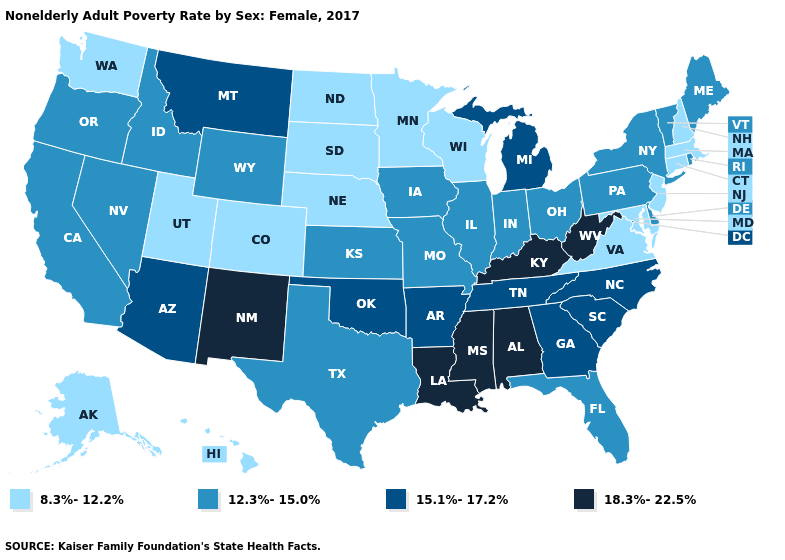What is the value of Tennessee?
Answer briefly. 15.1%-17.2%. Name the states that have a value in the range 12.3%-15.0%?
Keep it brief. California, Delaware, Florida, Idaho, Illinois, Indiana, Iowa, Kansas, Maine, Missouri, Nevada, New York, Ohio, Oregon, Pennsylvania, Rhode Island, Texas, Vermont, Wyoming. What is the highest value in the South ?
Short answer required. 18.3%-22.5%. Name the states that have a value in the range 12.3%-15.0%?
Short answer required. California, Delaware, Florida, Idaho, Illinois, Indiana, Iowa, Kansas, Maine, Missouri, Nevada, New York, Ohio, Oregon, Pennsylvania, Rhode Island, Texas, Vermont, Wyoming. Does Rhode Island have the lowest value in the Northeast?
Keep it brief. No. What is the value of Missouri?
Quick response, please. 12.3%-15.0%. What is the highest value in the USA?
Quick response, please. 18.3%-22.5%. Name the states that have a value in the range 15.1%-17.2%?
Be succinct. Arizona, Arkansas, Georgia, Michigan, Montana, North Carolina, Oklahoma, South Carolina, Tennessee. Does Missouri have a lower value than New Jersey?
Concise answer only. No. What is the lowest value in the USA?
Give a very brief answer. 8.3%-12.2%. What is the lowest value in the West?
Write a very short answer. 8.3%-12.2%. Does Mississippi have the highest value in the South?
Be succinct. Yes. How many symbols are there in the legend?
Answer briefly. 4. What is the value of Mississippi?
Give a very brief answer. 18.3%-22.5%. What is the highest value in states that border Delaware?
Concise answer only. 12.3%-15.0%. 